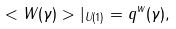<formula> <loc_0><loc_0><loc_500><loc_500>< W ( \gamma ) > | _ { U ( 1 ) } = q ^ { w } ( \gamma ) ,</formula> 